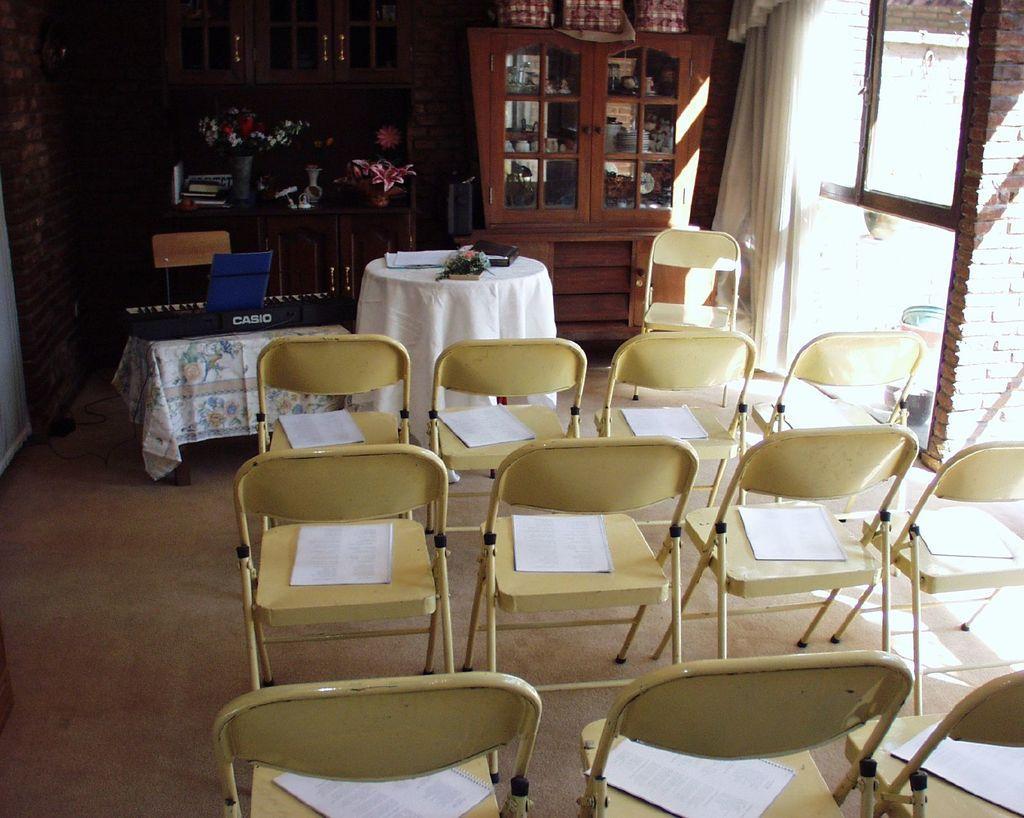Please provide a concise description of this image. In this image few chairs are having papers on it. There is a table having a piano on it. Behind there is a chair. Beside there is a table covered with cloth having few objects in it. Background there are few shelves having few books and flower vases in it. Beside there is a furniture. Right side there is a brick wall having a window to it. 